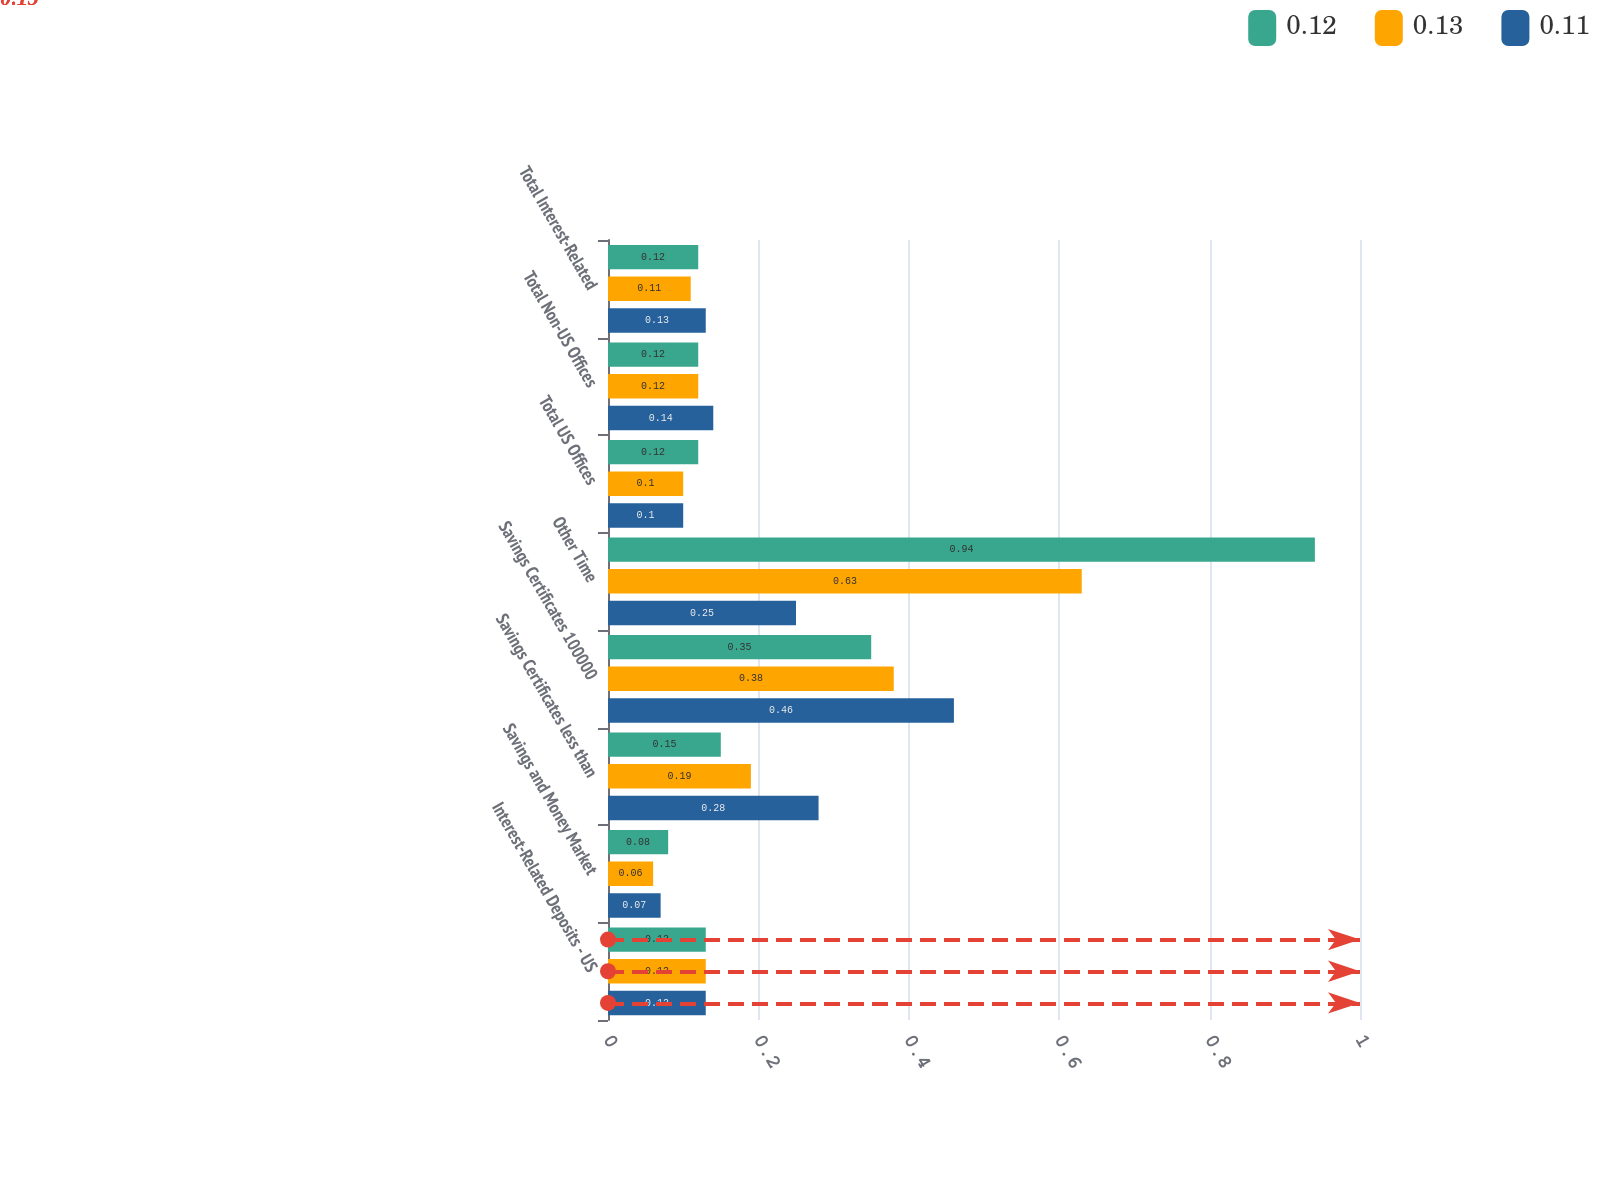<chart> <loc_0><loc_0><loc_500><loc_500><stacked_bar_chart><ecel><fcel>Interest-Related Deposits - US<fcel>Savings and Money Market<fcel>Savings Certificates less than<fcel>Savings Certificates 100000<fcel>Other Time<fcel>Total US Offices<fcel>Total Non-US Offices<fcel>Total Interest-Related<nl><fcel>0.12<fcel>0.13<fcel>0.08<fcel>0.15<fcel>0.35<fcel>0.94<fcel>0.12<fcel>0.12<fcel>0.12<nl><fcel>0.13<fcel>0.13<fcel>0.06<fcel>0.19<fcel>0.38<fcel>0.63<fcel>0.1<fcel>0.12<fcel>0.11<nl><fcel>0.11<fcel>0.13<fcel>0.07<fcel>0.28<fcel>0.46<fcel>0.25<fcel>0.1<fcel>0.14<fcel>0.13<nl></chart> 